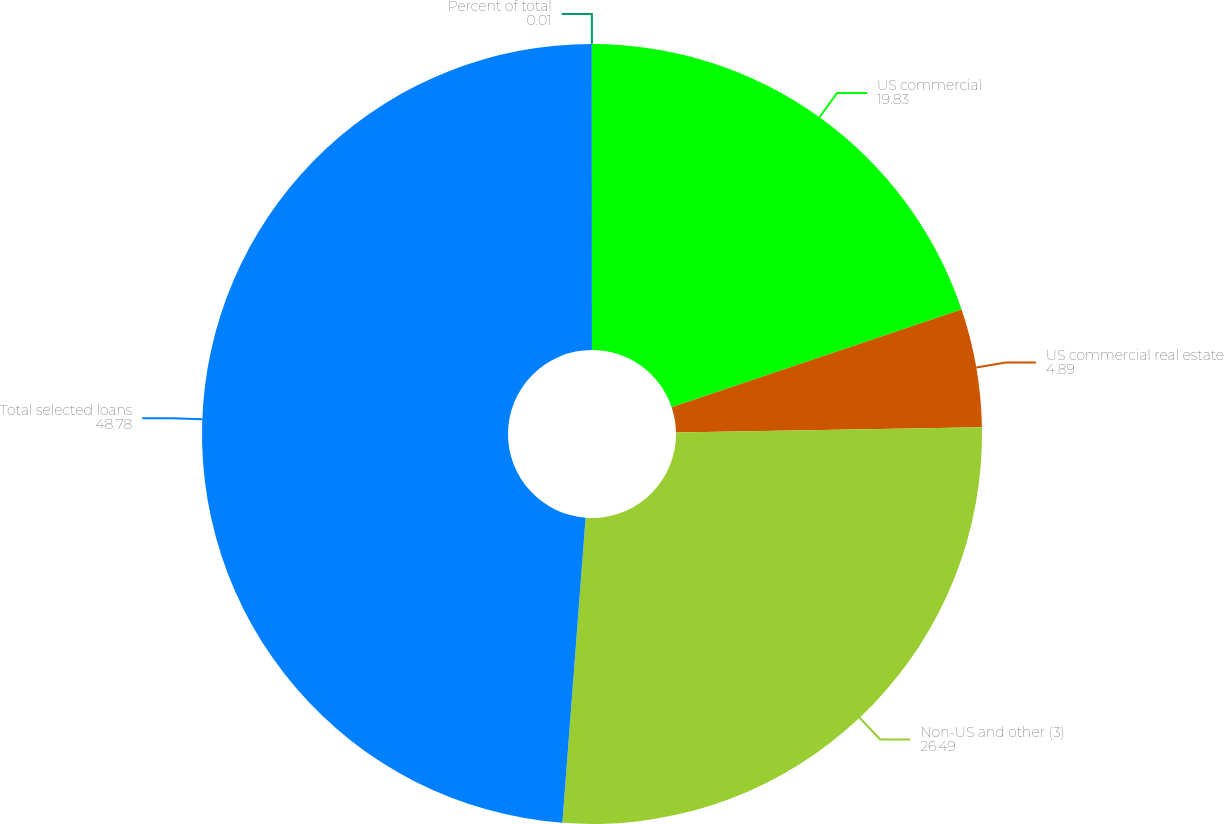<chart> <loc_0><loc_0><loc_500><loc_500><pie_chart><fcel>US commercial<fcel>US commercial real estate<fcel>Non-US and other (3)<fcel>Total selected loans<fcel>Percent of total<nl><fcel>19.83%<fcel>4.89%<fcel>26.49%<fcel>48.78%<fcel>0.01%<nl></chart> 